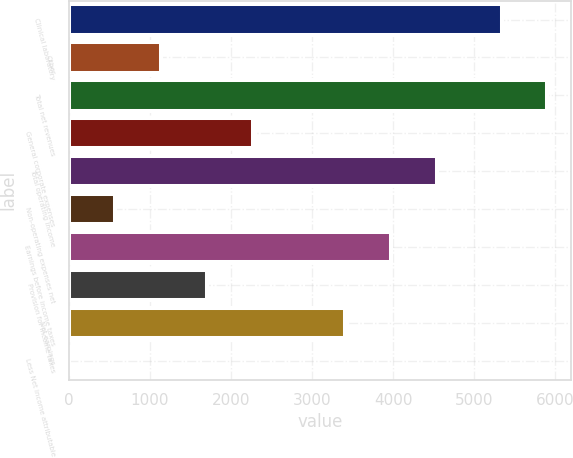<chart> <loc_0><loc_0><loc_500><loc_500><bar_chart><fcel>Clinical laboratory<fcel>Other<fcel>Total net revenues<fcel>General corporate expenses<fcel>Total operating income<fcel>Non-operating expenses net<fcel>Earnings before income taxes<fcel>Provision for income taxes<fcel>Net earnings<fcel>Less Net income attributable<nl><fcel>5336.4<fcel>1135.64<fcel>5903.37<fcel>2269.58<fcel>4537.46<fcel>568.67<fcel>3970.49<fcel>1702.61<fcel>3403.52<fcel>1.7<nl></chart> 